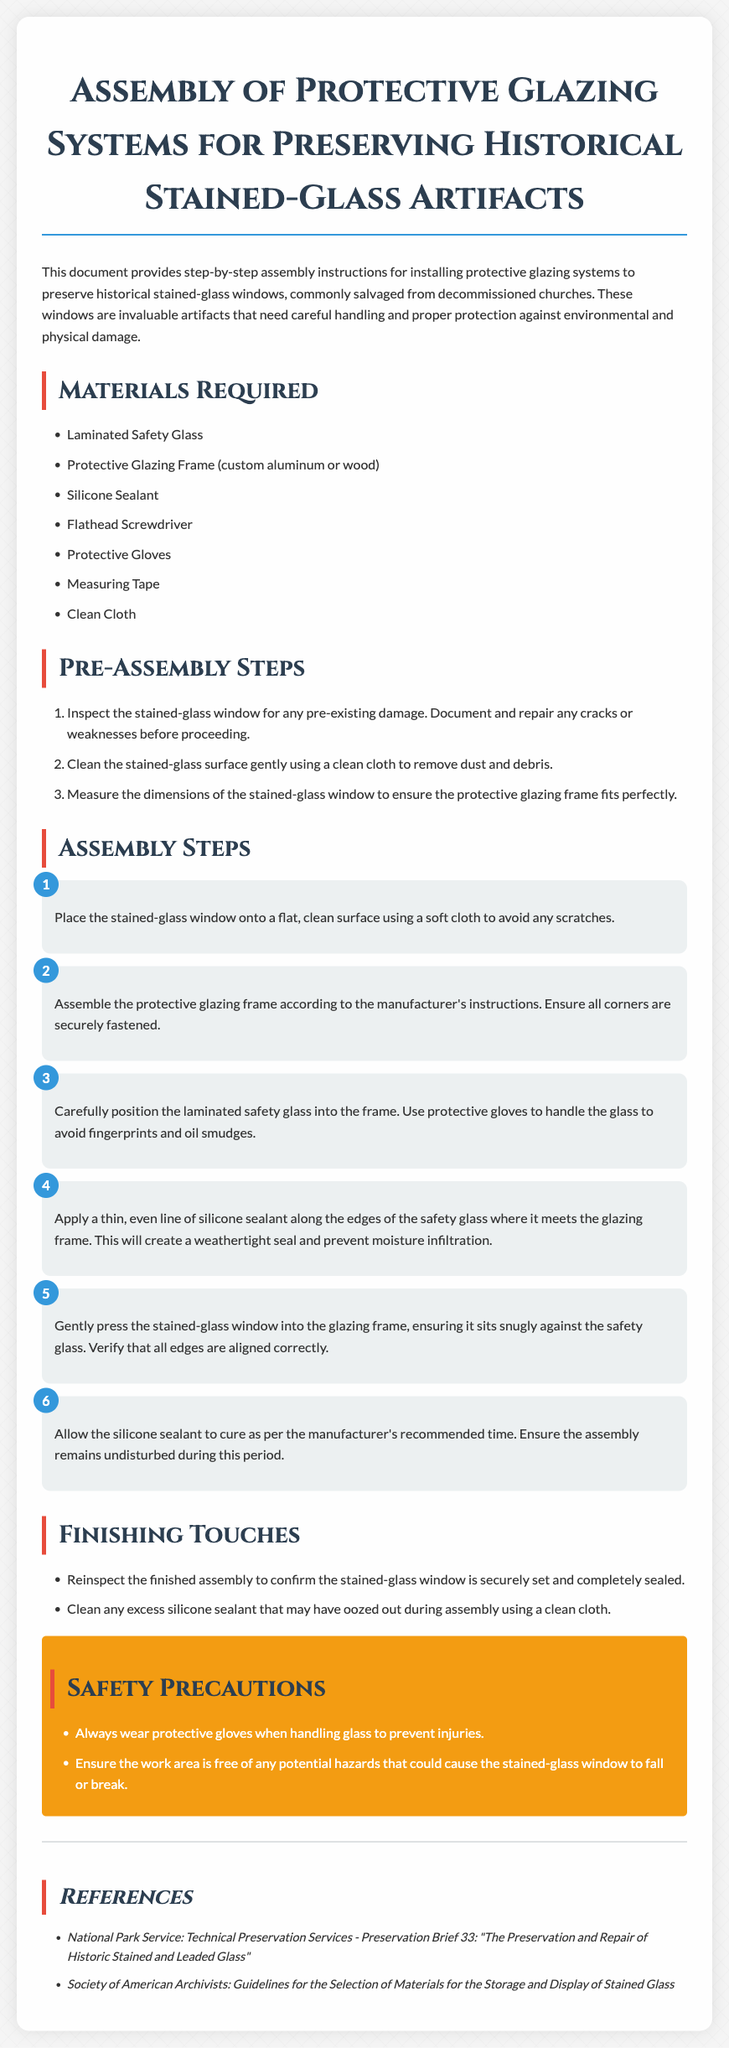what are the materials required for assembly? The materials required are listed in the "Materials Required" section, which includes Laminated Safety Glass, Protective Glazing Frame, Silicone Sealant, Flathead Screwdriver, Protective Gloves, Measuring Tape, and Clean Cloth.
Answer: Laminated Safety Glass, Protective Glazing Frame, Silicone Sealant, Flathead Screwdriver, Protective Gloves, Measuring Tape, Clean Cloth how many pre-assembly steps are there? The number of pre-assembly steps can be found in the "Pre-Assembly Steps" section; there are three steps listed.
Answer: 3 what should you do before measuring the stained-glass window? The instructions state to inspect the stained-glass window for any pre-existing damage and document and repair any cracks or weaknesses before measuring.
Answer: Inspect for damage what is the purpose of the silicone sealant? The document explains that silicone sealant creates a weathertight seal and prevents moisture infiltration along the edges of the safety glass.
Answer: Weathertight seal what is the last assembly step? The last assembly step mentioned in the document is to allow the silicone sealant to cure as per the manufacturer's recommended time.
Answer: Allow sealant to cure what should be cleaned after the assembly? The instructions state to clean any excess silicone sealant that may have oozed out during assembly using a clean cloth.
Answer: Excess silicone sealant what safety precaution is mentioned? A specific safety precaution mentioned is to always wear protective gloves when handling glass to prevent injuries.
Answer: Wear protective gloves how is the protective glazing frame described? The protective glazing frame is described as being custom aluminum or wood.
Answer: Custom aluminum or wood what is the purpose of the protective glazing systems? The protective glazing systems are designed to preserve historical stained-glass windows by protecting them from environmental and physical damage.
Answer: Preserve historical stained-glass windows 